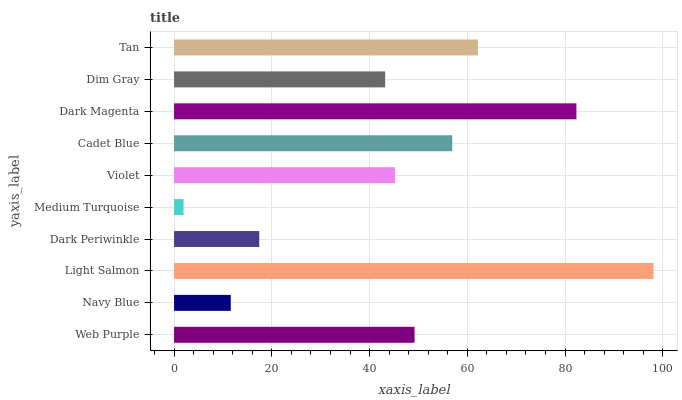Is Medium Turquoise the minimum?
Answer yes or no. Yes. Is Light Salmon the maximum?
Answer yes or no. Yes. Is Navy Blue the minimum?
Answer yes or no. No. Is Navy Blue the maximum?
Answer yes or no. No. Is Web Purple greater than Navy Blue?
Answer yes or no. Yes. Is Navy Blue less than Web Purple?
Answer yes or no. Yes. Is Navy Blue greater than Web Purple?
Answer yes or no. No. Is Web Purple less than Navy Blue?
Answer yes or no. No. Is Web Purple the high median?
Answer yes or no. Yes. Is Violet the low median?
Answer yes or no. Yes. Is Light Salmon the high median?
Answer yes or no. No. Is Medium Turquoise the low median?
Answer yes or no. No. 